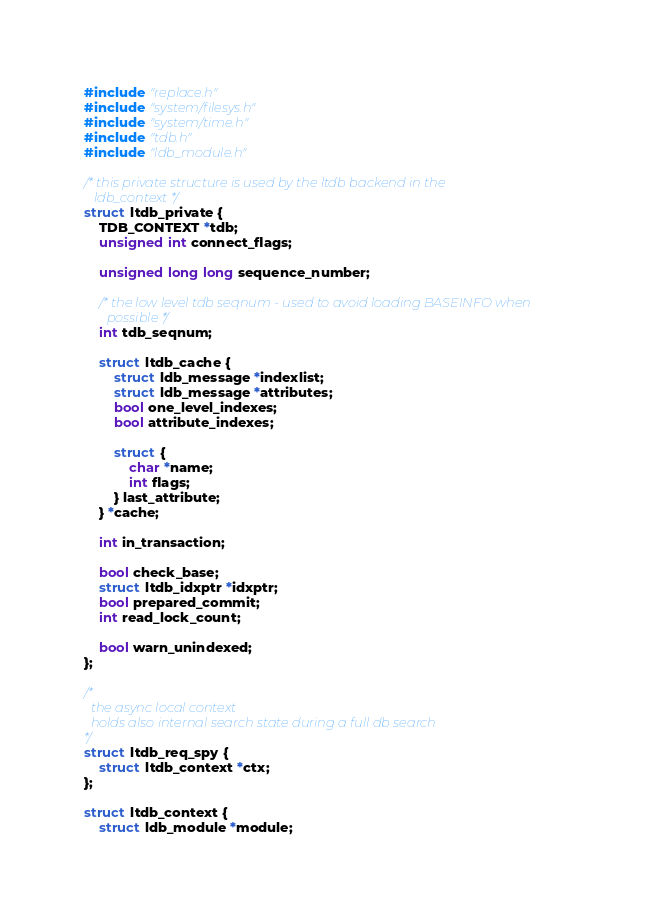Convert code to text. <code><loc_0><loc_0><loc_500><loc_500><_C_>#include "replace.h"
#include "system/filesys.h"
#include "system/time.h"
#include "tdb.h"
#include "ldb_module.h"

/* this private structure is used by the ltdb backend in the
   ldb_context */
struct ltdb_private {
	TDB_CONTEXT *tdb;
	unsigned int connect_flags;
	
	unsigned long long sequence_number;

	/* the low level tdb seqnum - used to avoid loading BASEINFO when
	   possible */
	int tdb_seqnum;

	struct ltdb_cache {
		struct ldb_message *indexlist;
		struct ldb_message *attributes;
		bool one_level_indexes;
		bool attribute_indexes;

		struct {
			char *name;
			int flags;
		} last_attribute;
	} *cache;

	int in_transaction;

	bool check_base;
	struct ltdb_idxptr *idxptr;
	bool prepared_commit;
	int read_lock_count;

	bool warn_unindexed;
};

/*
  the async local context
  holds also internal search state during a full db search
*/
struct ltdb_req_spy {
	struct ltdb_context *ctx;
};

struct ltdb_context {
	struct ldb_module *module;</code> 